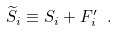Convert formula to latex. <formula><loc_0><loc_0><loc_500><loc_500>\widetilde { S } _ { i } \equiv S _ { i } + F _ { i } ^ { \prime } \ .</formula> 